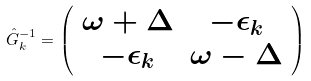Convert formula to latex. <formula><loc_0><loc_0><loc_500><loc_500>\hat { G } _ { k } ^ { - 1 } = \left ( \begin{array} { c c } \omega + \Delta & - \epsilon _ { k } \\ - \epsilon _ { k } & \omega - \Delta \end{array} \right )</formula> 